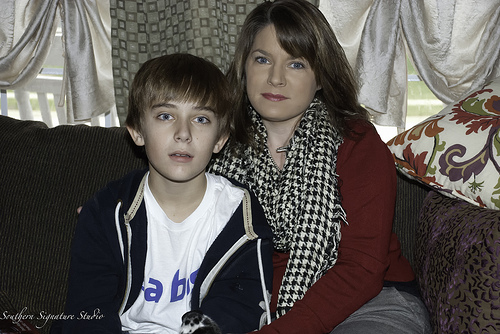<image>
Can you confirm if the boy is to the left of the lady? No. The boy is not to the left of the lady. From this viewpoint, they have a different horizontal relationship. Is there a boy in front of the girl? Yes. The boy is positioned in front of the girl, appearing closer to the camera viewpoint. 